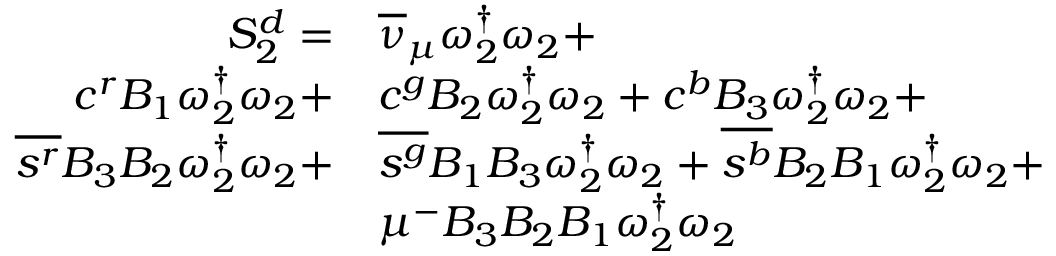<formula> <loc_0><loc_0><loc_500><loc_500>\begin{array} { r l } { S _ { 2 } ^ { d } = } & { { \overline { \nu } _ { \mu } } \omega _ { 2 } ^ { \dagger } \omega _ { 2 } + } \\ { { c } ^ { r } { B _ { 1 } } \omega _ { 2 } ^ { \dagger } \omega _ { 2 } + } & { { c } ^ { g } { B _ { 2 } } \omega _ { 2 } ^ { \dagger } \omega _ { 2 } + { c } ^ { b } { B _ { 3 } } \omega _ { 2 } ^ { \dagger } \omega _ { 2 } + } \\ { \overline { { s ^ { r } } } { B _ { 3 } } { B _ { 2 } } \omega _ { 2 } ^ { \dagger } \omega _ { 2 } + } & { \overline { { s ^ { g } } } { B _ { 1 } } { B _ { 3 } } \omega _ { 2 } ^ { \dagger } \omega _ { 2 } + \overline { { s ^ { b } } } { B _ { 2 } } { B _ { 1 } } \omega _ { 2 } ^ { \dagger } \omega _ { 2 } + } \\ & { \mu ^ { - } { B _ { 3 } } { B _ { 2 } } { B _ { 1 } } \omega _ { 2 } ^ { \dagger } \omega _ { 2 } } \end{array}</formula> 